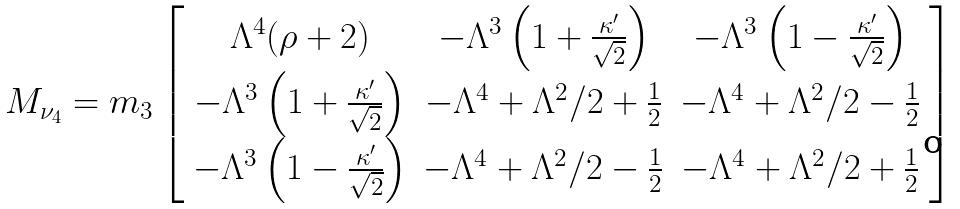<formula> <loc_0><loc_0><loc_500><loc_500>M _ { \nu _ { 4 } } = m _ { 3 } \left [ \begin{array} { c c c } \Lambda ^ { 4 } ( \rho + 2 ) & - \Lambda ^ { 3 } \left ( 1 + \frac { \kappa ^ { \prime } } { \sqrt { 2 } } \right ) & - \Lambda ^ { 3 } \left ( 1 - \frac { \kappa ^ { \prime } } { \sqrt { 2 } } \right ) \\ - \Lambda ^ { 3 } \left ( 1 + \frac { \kappa ^ { \prime } } { \sqrt { 2 } } \right ) & - \Lambda ^ { 4 } + \Lambda ^ { 2 } / 2 + \frac { 1 } { 2 } & - \Lambda ^ { 4 } + \Lambda ^ { 2 } / 2 - \frac { 1 } { 2 } \\ - \Lambda ^ { 3 } \left ( 1 - \frac { \kappa ^ { \prime } } { \sqrt { 2 } } \right ) & - \Lambda ^ { 4 } + \Lambda ^ { 2 } / 2 - \frac { 1 } { 2 } & - \Lambda ^ { 4 } + \Lambda ^ { 2 } / 2 + \frac { 1 } { 2 } \end{array} \right ]</formula> 